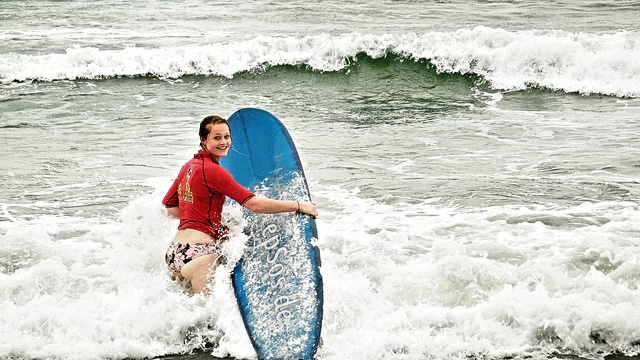Describe the objects in this image and their specific colors. I can see surfboard in gray, lightgray, teal, and darkgray tones and people in gray, brown, tan, and lightgray tones in this image. 